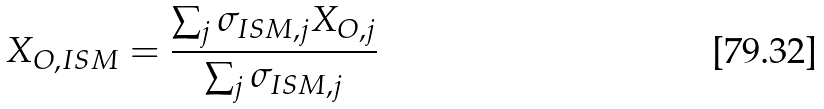Convert formula to latex. <formula><loc_0><loc_0><loc_500><loc_500>X _ { O , I S M } = \frac { \sum _ { j } \sigma _ { I S M , j } X _ { O , j } } { \sum _ { j } \sigma _ { I S M , j } }</formula> 